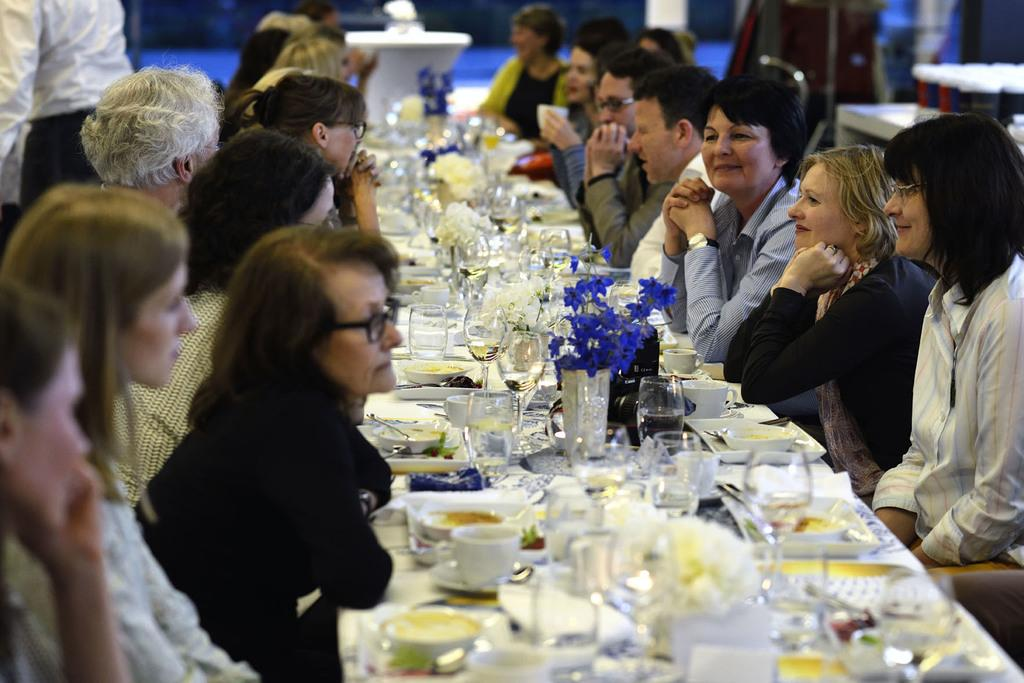What are the people in the image doing? There is a group of people sitting on chairs in the image. What objects can be seen on the table in the image? On the table, there is a cup, a saucer, a bowl, food, a glass, and a flower vase. How much does the beggar charge for their services in the image? There is no beggar present in the image, so it is not possible to determine their services or charges. 